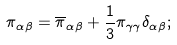Convert formula to latex. <formula><loc_0><loc_0><loc_500><loc_500>\pi _ { \alpha \beta } = \overline { \pi } _ { \alpha \beta } + \frac { 1 } { 3 } \pi _ { \gamma \gamma } \delta _ { \alpha \beta } ;</formula> 